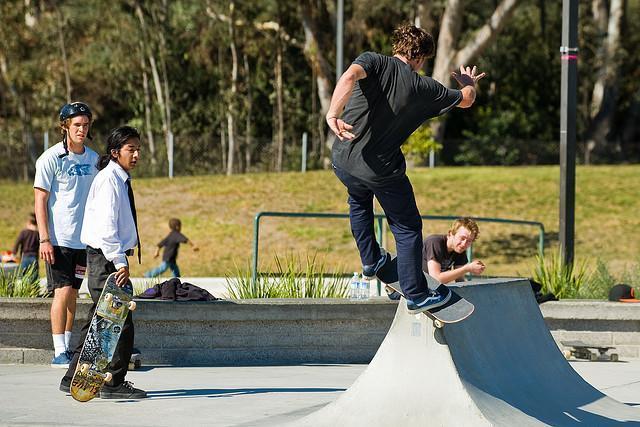How many people are in performing a trick?
Give a very brief answer. 1. How many men are standing on the left?
Give a very brief answer. 2. How many people are in the picture?
Give a very brief answer. 4. How many skateboards can you see?
Give a very brief answer. 1. 